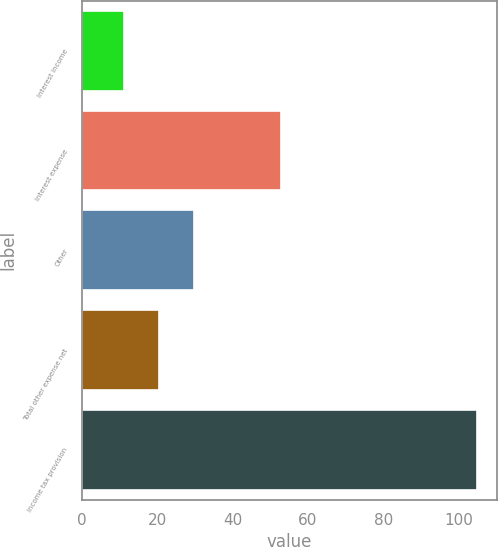Convert chart to OTSL. <chart><loc_0><loc_0><loc_500><loc_500><bar_chart><fcel>Interest income<fcel>Interest expense<fcel>Other<fcel>Total other expense net<fcel>Income tax provision<nl><fcel>11<fcel>52.9<fcel>29.8<fcel>20.4<fcel>105<nl></chart> 